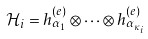<formula> <loc_0><loc_0><loc_500><loc_500>\mathcal { H } _ { i } = h ^ { ( e ) } _ { \alpha _ { 1 } } \otimes \dots \otimes h ^ { ( e ) } _ { \alpha _ { \kappa _ { i } } }</formula> 